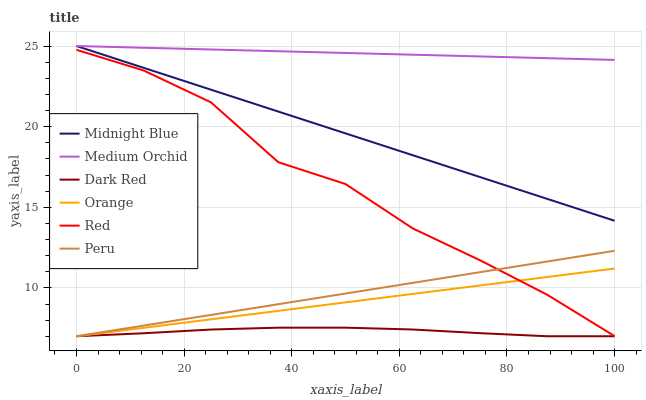Does Dark Red have the minimum area under the curve?
Answer yes or no. Yes. Does Medium Orchid have the maximum area under the curve?
Answer yes or no. Yes. Does Medium Orchid have the minimum area under the curve?
Answer yes or no. No. Does Dark Red have the maximum area under the curve?
Answer yes or no. No. Is Orange the smoothest?
Answer yes or no. Yes. Is Red the roughest?
Answer yes or no. Yes. Is Dark Red the smoothest?
Answer yes or no. No. Is Dark Red the roughest?
Answer yes or no. No. Does Dark Red have the lowest value?
Answer yes or no. Yes. Does Medium Orchid have the lowest value?
Answer yes or no. No. Does Medium Orchid have the highest value?
Answer yes or no. Yes. Does Dark Red have the highest value?
Answer yes or no. No. Is Peru less than Medium Orchid?
Answer yes or no. Yes. Is Midnight Blue greater than Orange?
Answer yes or no. Yes. Does Orange intersect Red?
Answer yes or no. Yes. Is Orange less than Red?
Answer yes or no. No. Is Orange greater than Red?
Answer yes or no. No. Does Peru intersect Medium Orchid?
Answer yes or no. No. 